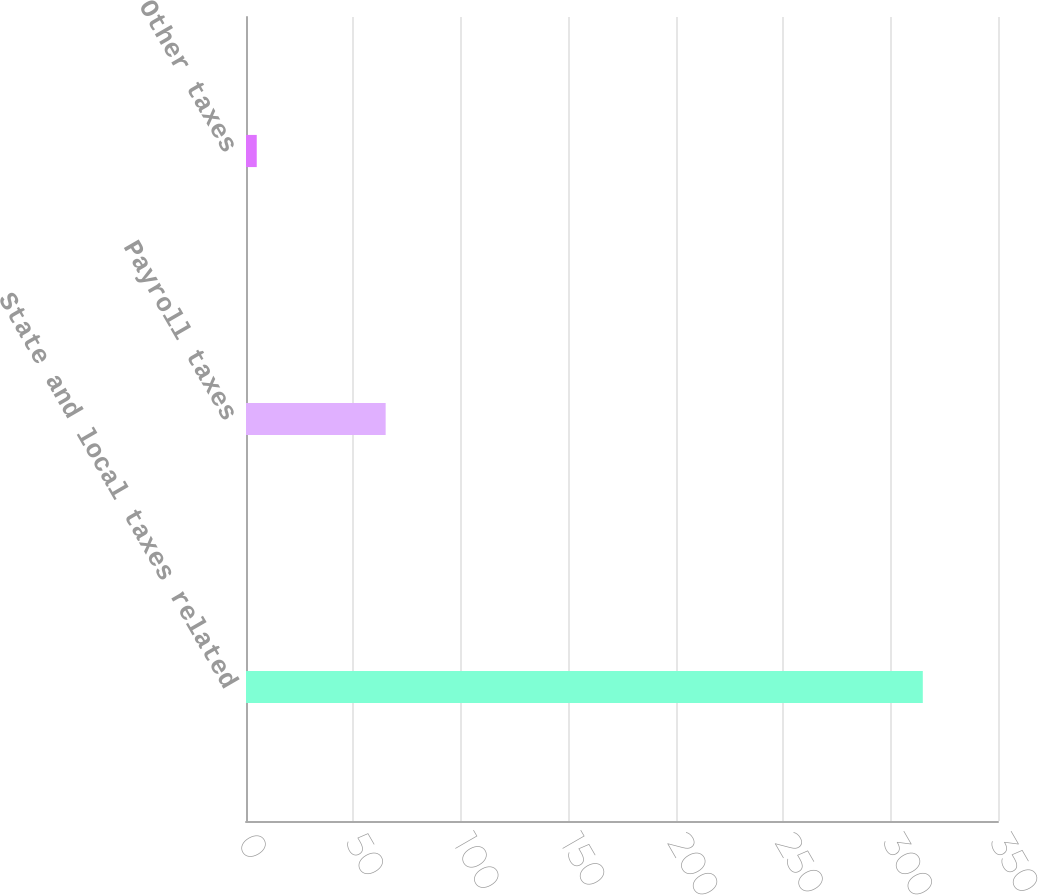Convert chart to OTSL. <chart><loc_0><loc_0><loc_500><loc_500><bar_chart><fcel>State and local taxes related<fcel>Payroll taxes<fcel>Other taxes<nl><fcel>315<fcel>65<fcel>5<nl></chart> 